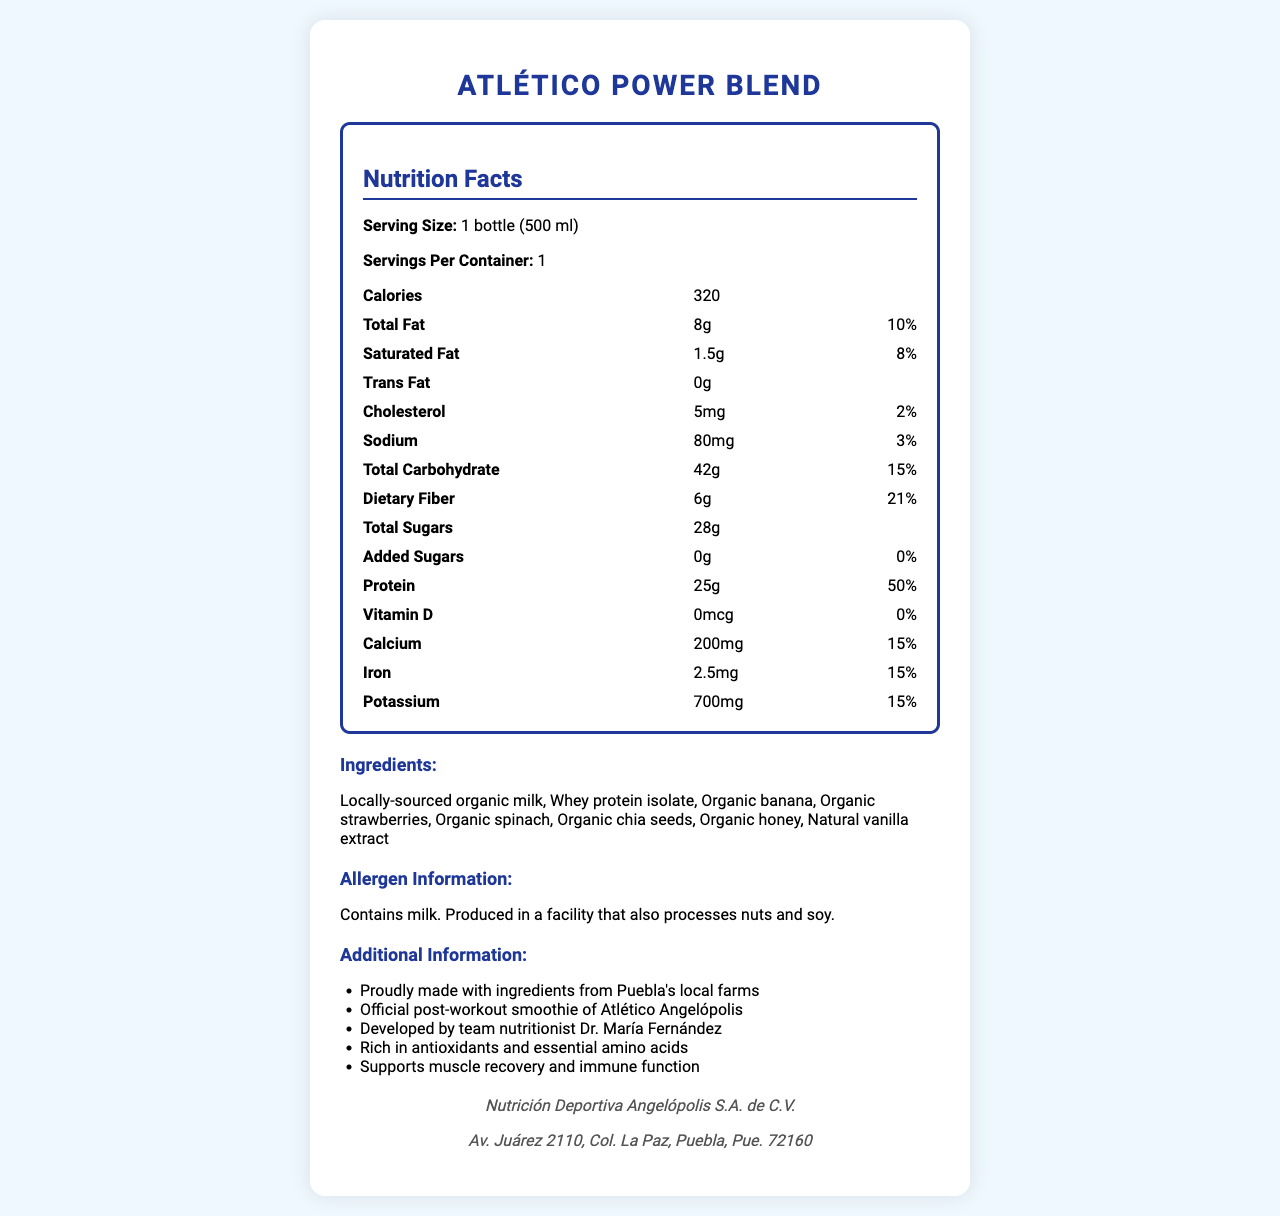what is the serving size? The serving size is explicitly mentioned in the document as "1 bottle (500 ml)."
Answer: 1 bottle (500 ml) how many calories are in one serving? The document states that each serving contains 320 calories.
Answer: 320 calories how much protein does the smoothie provide per serving? The document lists 25 grams of protein per serving.
Answer: 25 g which ingredient could be a potential allergen for some consumers? The allergen information in the document specifies that the product contains milk.
Answer: Milk where is Nutrición Deportiva Angelópolis S.A. de C.V. located? The manufacturer's address is provided at the bottom of the document.
Answer: Av. Juárez 2110, Col. La Paz, Puebla, Pue. 72160 which nutrient contributes to muscle recovery and immune function according to the additional information? The additional information mentions that the smoothie "supports muscle recovery and immune function," which is typically associated with protein content.
Answer: Protein which ingredient provides natural sweetness to the smoothie? A. Organic honey B. Organic spinach C. Whey protein isolate D. Natural vanilla extract Organic honey is known for its natural sweetness, and it is listed as one of the ingredients.
Answer: A. Organic honey What is the main sweetener used in Atlético Power Blend? A. Added sugars B. Organic honey C. Artificial sweeteners D. Corn syrup The only sweetener listed in the ingredients is "Organic honey," and there are no added sugars or artificial sweeteners mentioned.
Answer: B. Organic honey is there any added sugar in this smoothie? The document explicitly states that there are 0 grams of added sugars.
Answer: No does the smoothie contain any nuts? The allergen information mentions it is produced in a facility that processes nuts, but it does not specify whether the smoothie itself contains nuts.
Answer: Not enough information summarize the main features of the Atlético Power Blend smoothie. The document provides detailed nutritional information, ingredients, allergen information, additional benefits, and manufacturer details, highlighting the product's features and health benefits for athletes.
Answer: The Atlético Power Blend is a locally-sourced, protein-rich post-workout smoothie favored by Atlético Angelópolis players. It has 320 calories per 500 ml bottle, provides 25 grams of protein, and contains ingredients like organic milk, whey protein isolate, organic banana, and organic honey. It is manufactured by Nutrición Deportiva Angelópolis S.A. de C.V. in Puebla and supports muscle recovery and immune function. 